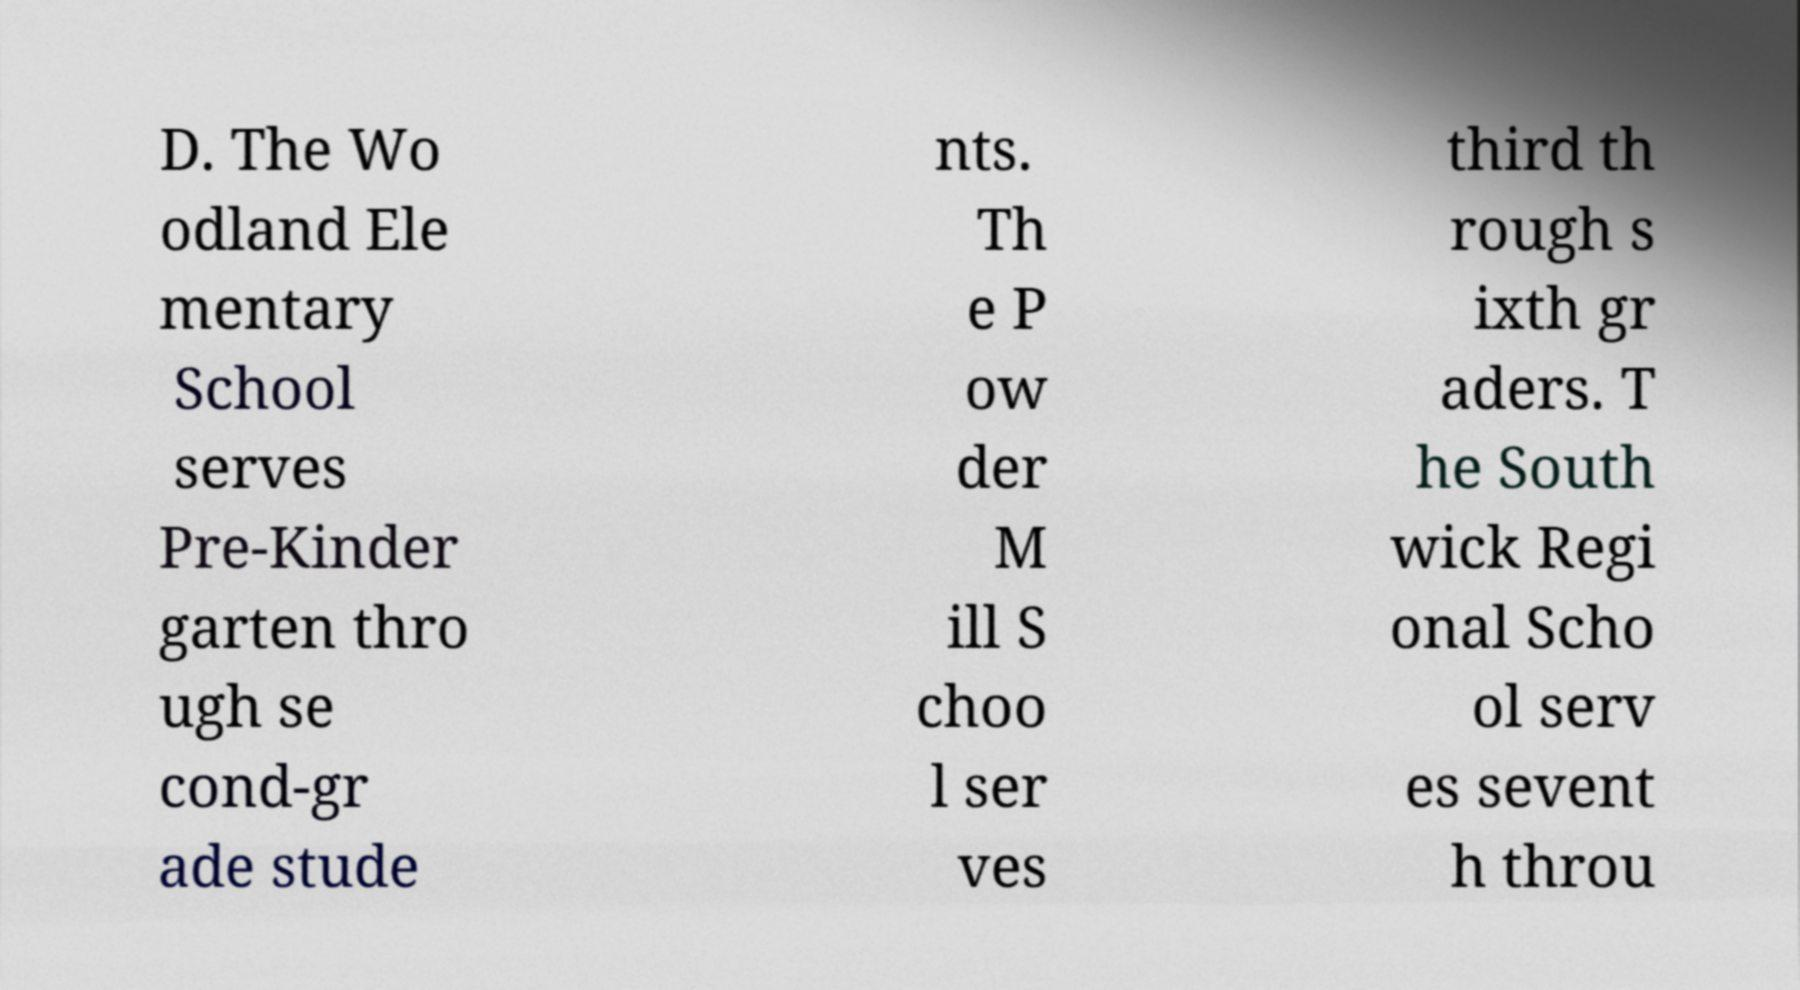Can you read and provide the text displayed in the image?This photo seems to have some interesting text. Can you extract and type it out for me? D. The Wo odland Ele mentary School serves Pre-Kinder garten thro ugh se cond-gr ade stude nts. Th e P ow der M ill S choo l ser ves third th rough s ixth gr aders. T he South wick Regi onal Scho ol serv es sevent h throu 